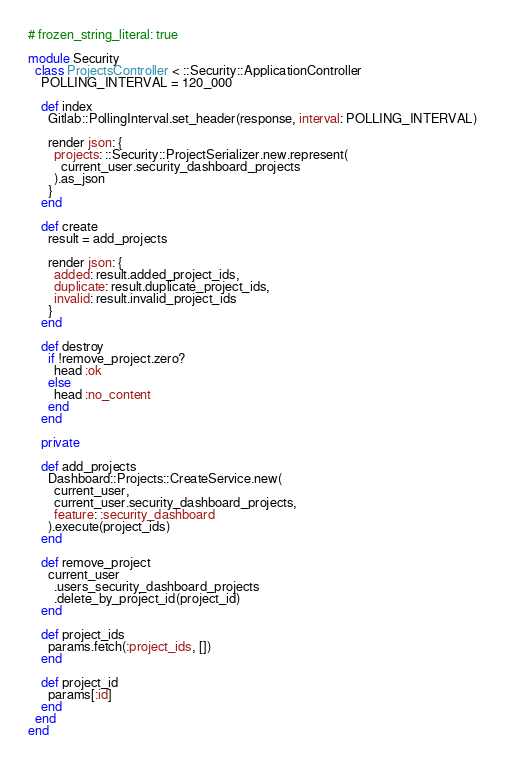Convert code to text. <code><loc_0><loc_0><loc_500><loc_500><_Ruby_># frozen_string_literal: true

module Security
  class ProjectsController < ::Security::ApplicationController
    POLLING_INTERVAL = 120_000

    def index
      Gitlab::PollingInterval.set_header(response, interval: POLLING_INTERVAL)

      render json: {
        projects: ::Security::ProjectSerializer.new.represent(
          current_user.security_dashboard_projects
        ).as_json
      }
    end

    def create
      result = add_projects

      render json: {
        added: result.added_project_ids,
        duplicate: result.duplicate_project_ids,
        invalid: result.invalid_project_ids
      }
    end

    def destroy
      if !remove_project.zero?
        head :ok
      else
        head :no_content
      end
    end

    private

    def add_projects
      Dashboard::Projects::CreateService.new(
        current_user,
        current_user.security_dashboard_projects,
        feature: :security_dashboard
      ).execute(project_ids)
    end

    def remove_project
      current_user
        .users_security_dashboard_projects
        .delete_by_project_id(project_id)
    end

    def project_ids
      params.fetch(:project_ids, [])
    end

    def project_id
      params[:id]
    end
  end
end
</code> 